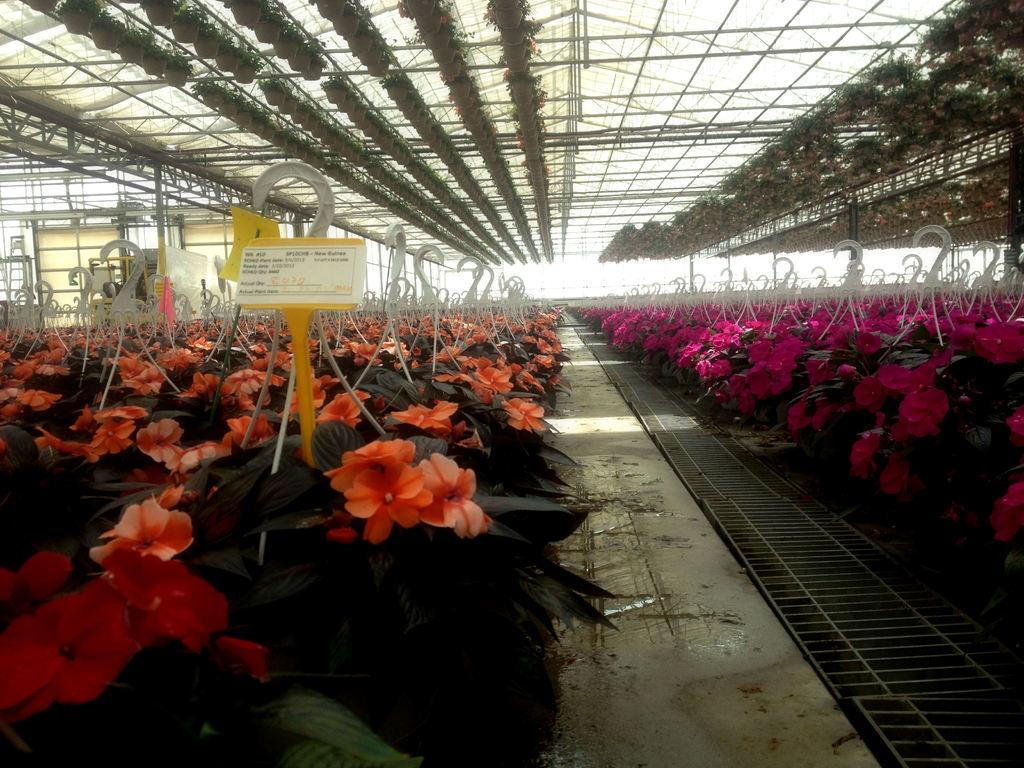What type of vegetation can be seen on the right side of the image? There are plants and flowers on the right side of the image. What type of vegetation can be seen on the left side of the image? There are plants and flowers on the left side of the image. What is located in the center of the image? There is a walkway in the center of the image. What type of plants can be seen at the top of the image? There are house plants visible at the top of the image. What type of meat is being prepared on the walkway in the image? There is no meat or preparation of food visible in the image; it features plants and flowers on both sides, a walkway in the center, and house plants at the top. 